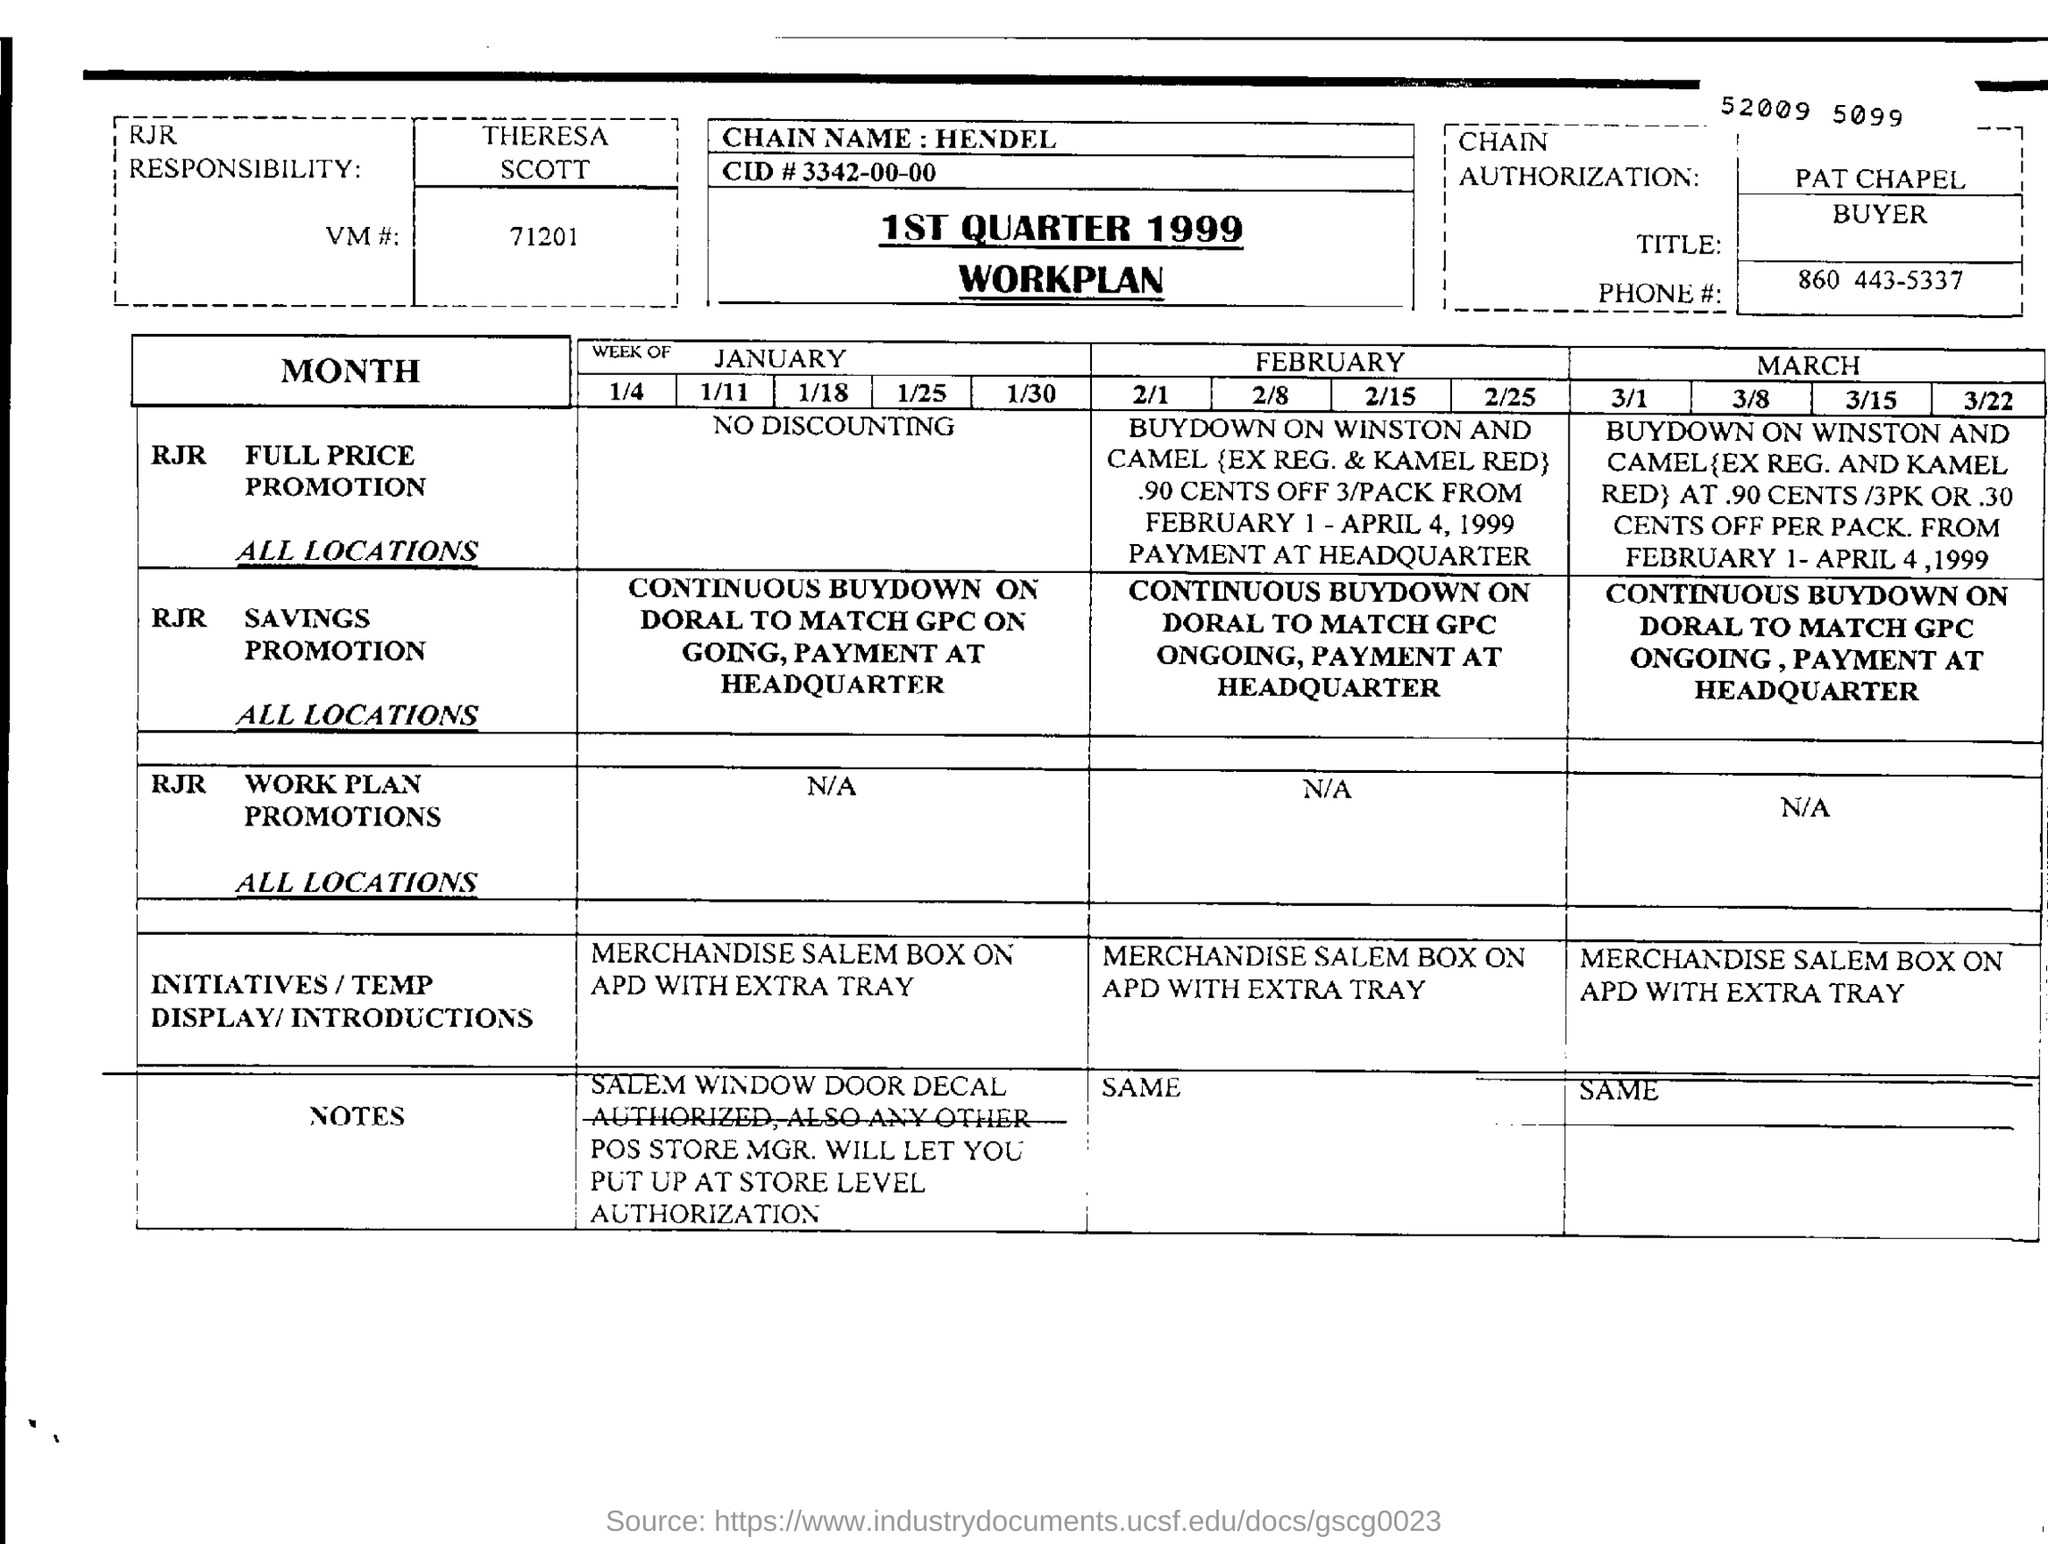To which year does the workplan applicable?
Your answer should be compact. 1999. Who is responsible for chain authorisation?
Provide a succinct answer. Pat chapel. 